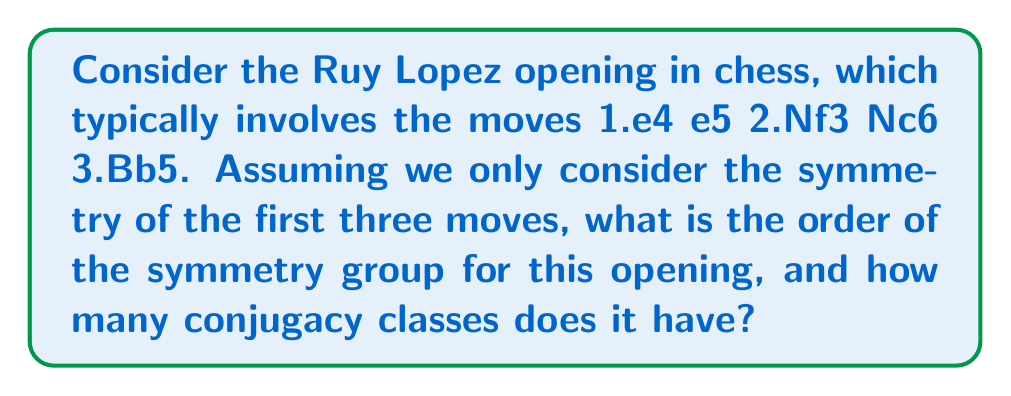Can you solve this math problem? To solve this problem, let's follow these steps:

1) First, we need to understand what symmetries are possible in this opening:
   - The board can be rotated 180 degrees (2-fold rotation)
   - The sequence of moves can be reversed (time reversal)

2) These symmetries form a group with the following elements:
   - e: Identity (no change)
   - r: 180-degree rotation
   - t: Time reversal
   - rt: Rotation followed by time reversal

3) To determine the order of the group:
   - Count the number of distinct elements: e, r, t, rt
   - The order of the group is 4

4) To find the number of conjugacy classes, we need to check which elements are conjugate to each other:
   - {e} is always its own conjugacy class
   - r^2 = e, so r is of order 2
   - t^2 = e, so t is of order 2
   - (rt)^2 = e, so rt is of order 2

5) In a group of order 4 where all non-identity elements have order 2, each element forms its own conjugacy class.

Therefore, there are 4 conjugacy classes: {e}, {r}, {t}, and {rt}.
Answer: Order: 4, Conjugacy classes: 4 